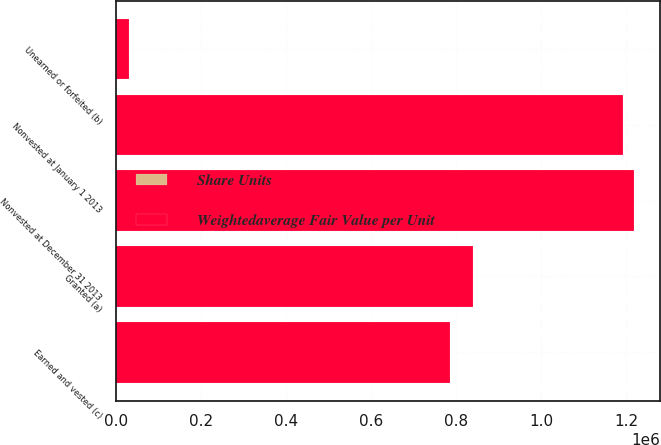Convert chart. <chart><loc_0><loc_0><loc_500><loc_500><stacked_bar_chart><ecel><fcel>Nonvested at January 1 2013<fcel>Granted (a)<fcel>Unearned or forfeited (b)<fcel>Earned and vested (c)<fcel>Nonvested at December 31 2013<nl><fcel>Weightedaverage Fair Value per Unit<fcel>1.19249e+06<fcel>840482<fcel>29730<fcel>784695<fcel>1.21854e+06<nl><fcel>Share Units<fcel>33.56<fcel>31.19<fcel>31.93<fcel>31.6<fcel>33.23<nl></chart> 